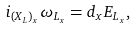<formula> <loc_0><loc_0><loc_500><loc_500>i _ { ( X _ { L } ) _ { x } } \omega _ { L _ { x } } = d _ { x } E _ { L _ { x } } ,</formula> 